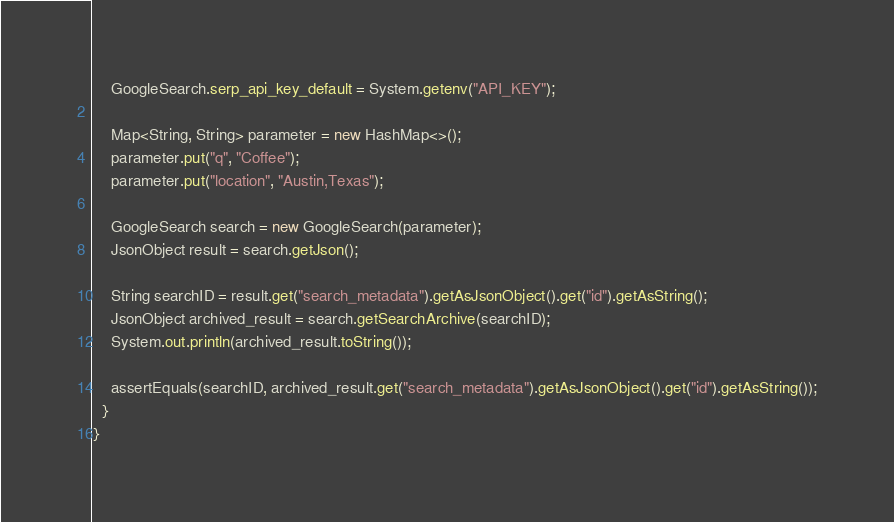<code> <loc_0><loc_0><loc_500><loc_500><_Java_>
    GoogleSearch.serp_api_key_default = System.getenv("API_KEY");

    Map<String, String> parameter = new HashMap<>();
    parameter.put("q", "Coffee");
    parameter.put("location", "Austin,Texas");

    GoogleSearch search = new GoogleSearch(parameter);
    JsonObject result = search.getJson();

    String searchID = result.get("search_metadata").getAsJsonObject().get("id").getAsString();
    JsonObject archived_result = search.getSearchArchive(searchID);
    System.out.println(archived_result.toString());

    assertEquals(searchID, archived_result.get("search_metadata").getAsJsonObject().get("id").getAsString());
  }
}</code> 